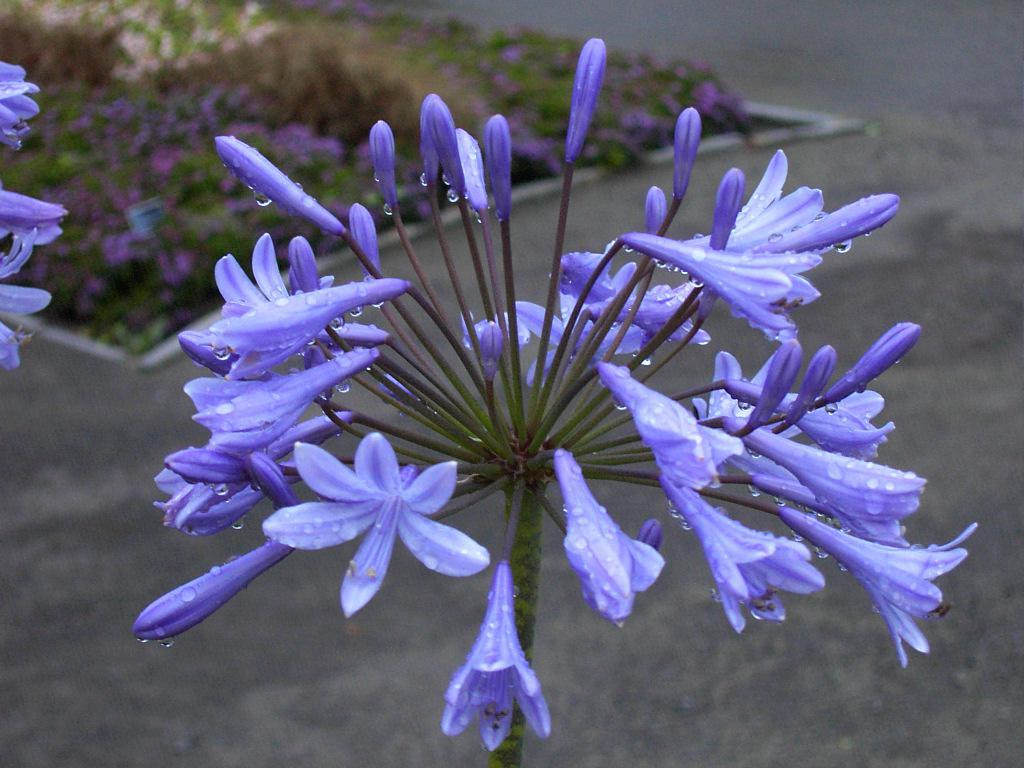What color are the flowers on the plant in the image? The flowers on the plant in the image are purple. How many flower plants can be seen on the land in the image? There are many flower plants on the land in the image. What type of silver material can be seen in the image? There is no silver material present in the image; it features only flower plants. What are the hands of the person in the image doing? There is no person present in the image, so their hands cannot be observed. 